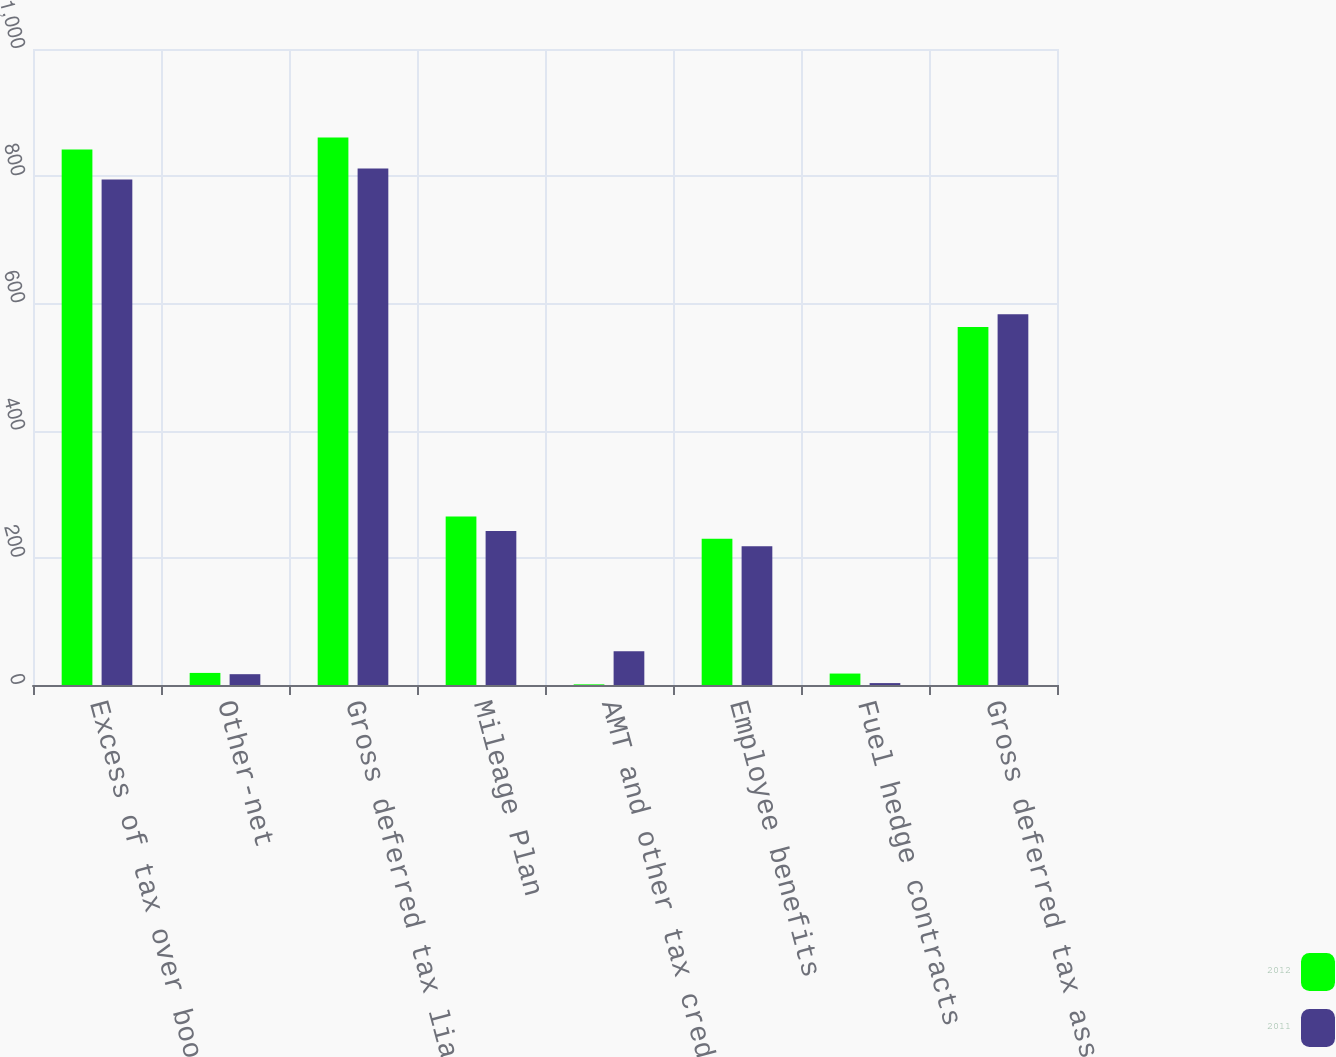Convert chart. <chart><loc_0><loc_0><loc_500><loc_500><stacked_bar_chart><ecel><fcel>Excess of tax over book<fcel>Other-net<fcel>Gross deferred tax liabilities<fcel>Mileage Plan<fcel>AMT and other tax credits<fcel>Employee benefits<fcel>Fuel hedge contracts<fcel>Gross deferred tax assets<nl><fcel>2012<fcel>842<fcel>19<fcel>861<fcel>265<fcel>1<fcel>230<fcel>18<fcel>563<nl><fcel>2011<fcel>795<fcel>17<fcel>812<fcel>242<fcel>53<fcel>218<fcel>3<fcel>583<nl></chart> 